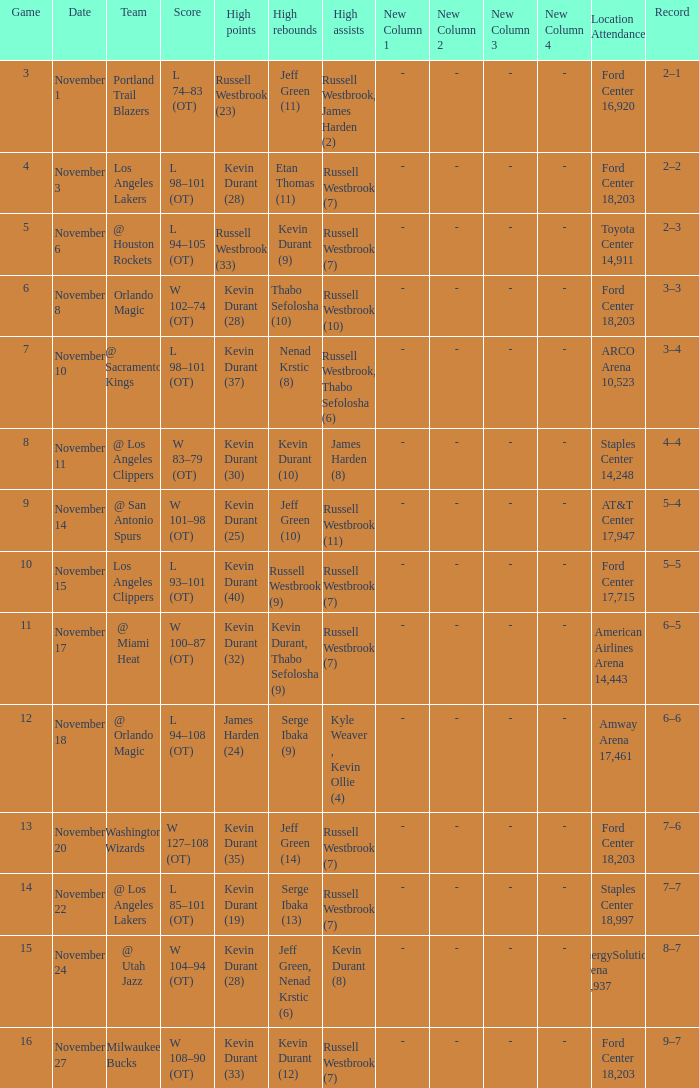Where was the game in which Kevin Durant (25) did the most high points played? AT&T Center 17,947. 